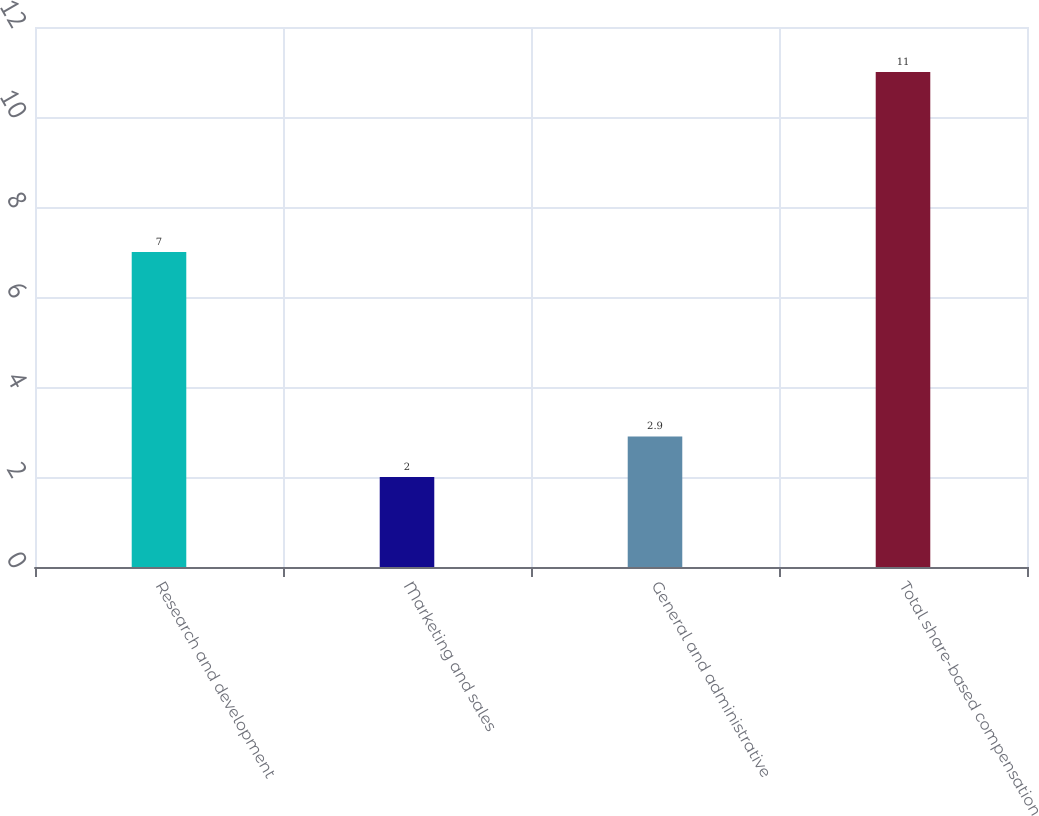Convert chart. <chart><loc_0><loc_0><loc_500><loc_500><bar_chart><fcel>Research and development<fcel>Marketing and sales<fcel>General and administrative<fcel>Total share-based compensation<nl><fcel>7<fcel>2<fcel>2.9<fcel>11<nl></chart> 